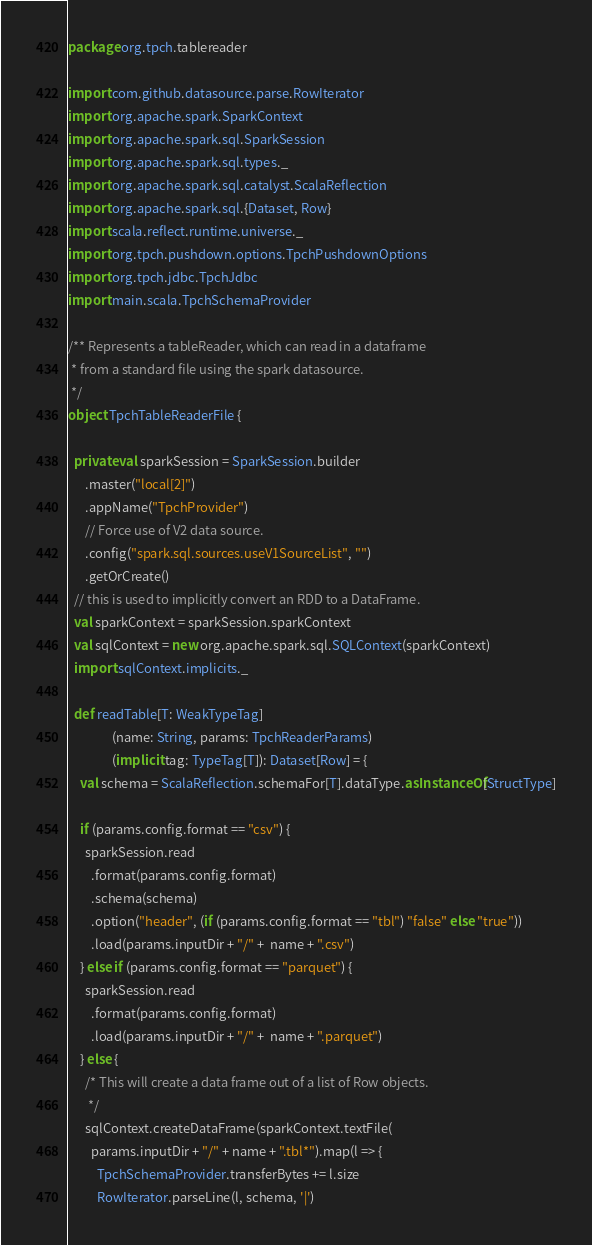Convert code to text. <code><loc_0><loc_0><loc_500><loc_500><_Scala_>package org.tpch.tablereader

import com.github.datasource.parse.RowIterator
import org.apache.spark.SparkContext
import org.apache.spark.sql.SparkSession
import org.apache.spark.sql.types._
import org.apache.spark.sql.catalyst.ScalaReflection
import org.apache.spark.sql.{Dataset, Row}
import scala.reflect.runtime.universe._
import org.tpch.pushdown.options.TpchPushdownOptions
import org.tpch.jdbc.TpchJdbc
import main.scala.TpchSchemaProvider

/** Represents a tableReader, which can read in a dataframe
 * from a standard file using the spark datasource.
 */
object TpchTableReaderFile {

  private val sparkSession = SparkSession.builder
      .master("local[2]")
      .appName("TpchProvider")
      // Force use of V2 data source.
      .config("spark.sql.sources.useV1SourceList", "")
      .getOrCreate()
  // this is used to implicitly convert an RDD to a DataFrame.
  val sparkContext = sparkSession.sparkContext
  val sqlContext = new org.apache.spark.sql.SQLContext(sparkContext)
  import sqlContext.implicits._

  def readTable[T: WeakTypeTag]
               (name: String, params: TpchReaderParams)
               (implicit tag: TypeTag[T]): Dataset[Row] = {
    val schema = ScalaReflection.schemaFor[T].dataType.asInstanceOf[StructType]

    if (params.config.format == "csv") {
      sparkSession.read
        .format(params.config.format)
        .schema(schema)
        .option("header", (if (params.config.format == "tbl") "false" else "true"))
        .load(params.inputDir + "/" +  name + ".csv")
    } else if (params.config.format == "parquet") {
      sparkSession.read
        .format(params.config.format)
        .load(params.inputDir + "/" +  name + ".parquet")
    } else {
      /* This will create a data frame out of a list of Row objects.
       */
      sqlContext.createDataFrame(sparkContext.textFile(
        params.inputDir + "/" + name + ".tbl*").map(l => {
          TpchSchemaProvider.transferBytes += l.size
          RowIterator.parseLine(l, schema, '|')</code> 